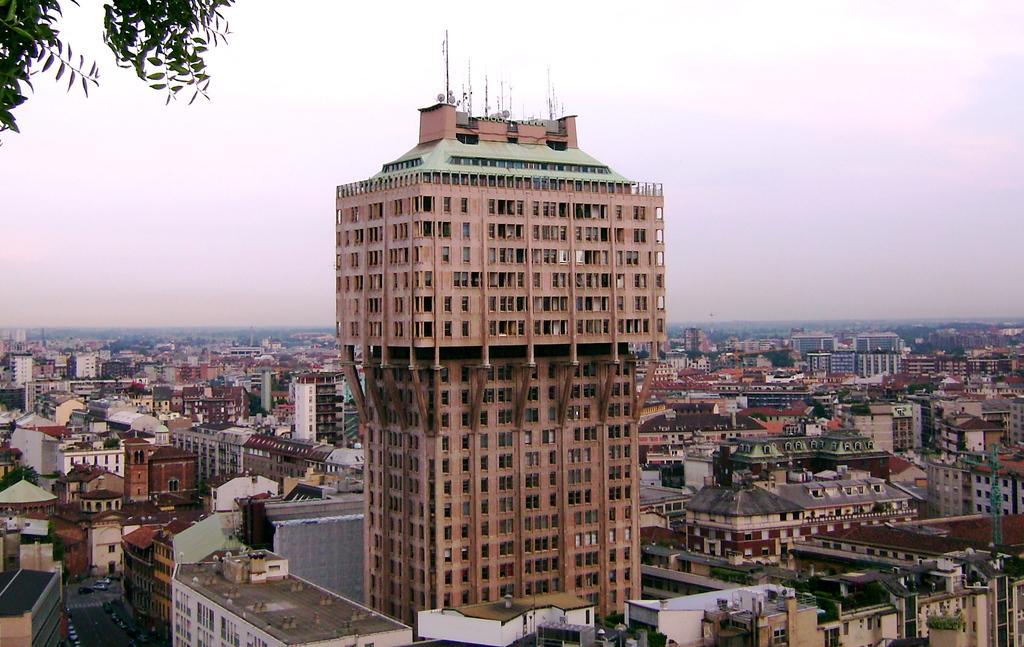In one or two sentences, can you explain what this image depicts? As we can see in the image there are buildings, windows, tree and at the top there is sky. 